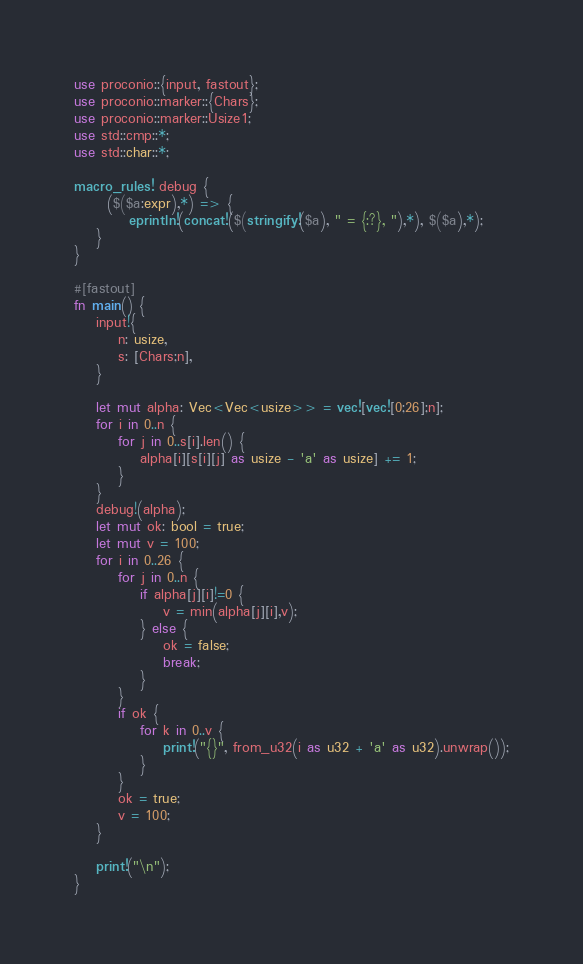Convert code to text. <code><loc_0><loc_0><loc_500><loc_500><_Rust_>use proconio::{input, fastout};
use proconio::marker::{Chars};
use proconio::marker::Usize1;
use std::cmp::*;
use std::char::*;

macro_rules! debug {
      ($($a:expr),*) => {
          eprintln!(concat!($(stringify!($a), " = {:?}, "),*), $($a),*);
    }
}

#[fastout]
fn main() {
    input!{
        n: usize,
        s: [Chars;n],
    }

    let mut alpha: Vec<Vec<usize>> = vec![vec![0;26];n];
    for i in 0..n {
        for j in 0..s[i].len() {
            alpha[i][s[i][j] as usize - 'a' as usize] += 1;
        }
    }
    debug!(alpha);
    let mut ok: bool = true;
    let mut v = 100;
    for i in 0..26 {
        for j in 0..n {
            if alpha[j][i]!=0 {
                v = min(alpha[j][i],v);
            } else {
                ok = false;
                break;
            }
        }
        if ok {
            for k in 0..v {
                print!("{}", from_u32(i as u32 + 'a' as u32).unwrap());
            }
        }
        ok = true;
        v = 100;
    }

    print!("\n");
}
</code> 